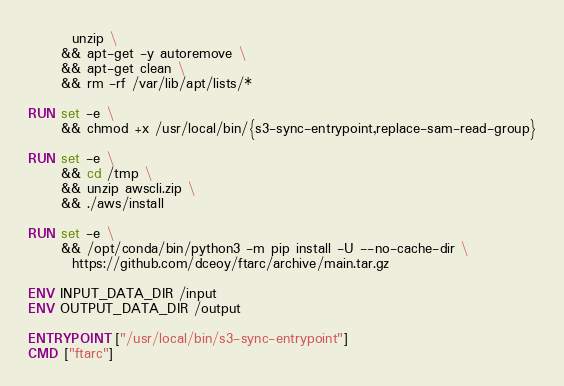Convert code to text. <code><loc_0><loc_0><loc_500><loc_500><_Dockerfile_>        unzip \
      && apt-get -y autoremove \
      && apt-get clean \
      && rm -rf /var/lib/apt/lists/*

RUN set -e \
      && chmod +x /usr/local/bin/{s3-sync-entrypoint,replace-sam-read-group}

RUN set -e \
      && cd /tmp \
      && unzip awscli.zip \
      && ./aws/install

RUN set -e \
      && /opt/conda/bin/python3 -m pip install -U --no-cache-dir \
        https://github.com/dceoy/ftarc/archive/main.tar.gz

ENV INPUT_DATA_DIR /input
ENV OUTPUT_DATA_DIR /output

ENTRYPOINT ["/usr/local/bin/s3-sync-entrypoint"]
CMD ["ftarc"]
</code> 